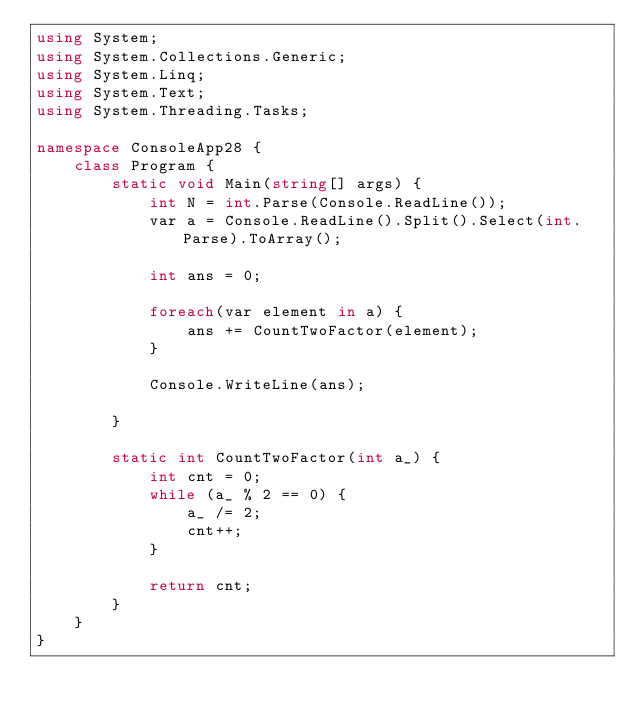Convert code to text. <code><loc_0><loc_0><loc_500><loc_500><_C#_>using System;
using System.Collections.Generic;
using System.Linq;
using System.Text;
using System.Threading.Tasks;

namespace ConsoleApp28 {
    class Program {
        static void Main(string[] args) {
            int N = int.Parse(Console.ReadLine());
            var a = Console.ReadLine().Split().Select(int.Parse).ToArray();

            int ans = 0;

            foreach(var element in a) {
                ans += CountTwoFactor(element);
            }

            Console.WriteLine(ans);

        }

        static int CountTwoFactor(int a_) {
            int cnt = 0;
            while (a_ % 2 == 0) {
                a_ /= 2;
                cnt++;
            }

            return cnt;
        }
    }
}
</code> 